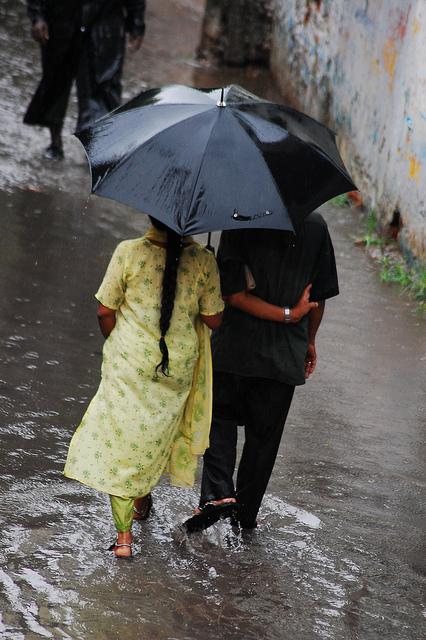Is the umbrella wet?
Give a very brief answer. Yes. What is covering the ground?
Write a very short answer. Water. What are the people walking in?
Keep it brief. Water. 